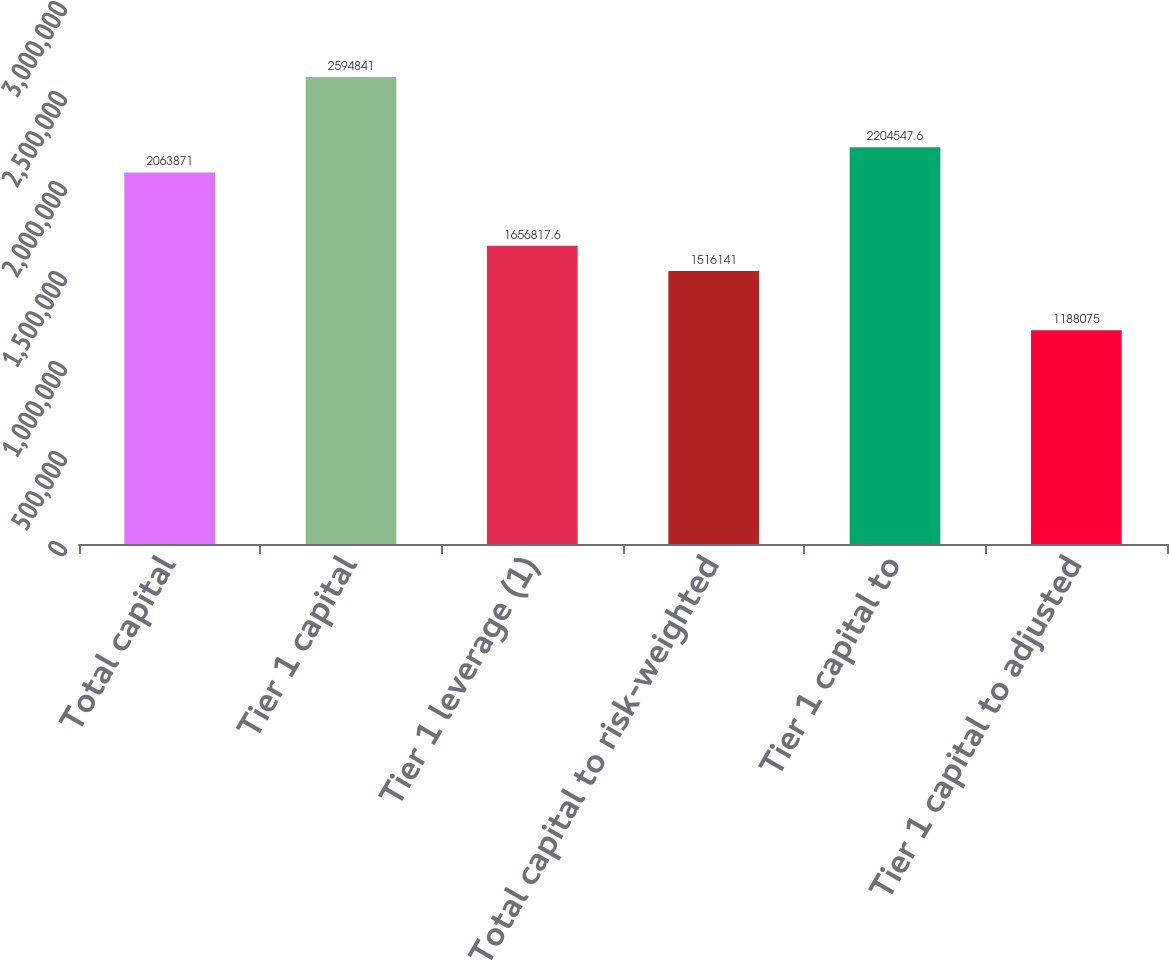<chart> <loc_0><loc_0><loc_500><loc_500><bar_chart><fcel>Total capital<fcel>Tier 1 capital<fcel>Tier 1 leverage (1)<fcel>Total capital to risk-weighted<fcel>Tier 1 capital to<fcel>Tier 1 capital to adjusted<nl><fcel>2.06387e+06<fcel>2.59484e+06<fcel>1.65682e+06<fcel>1.51614e+06<fcel>2.20455e+06<fcel>1.18808e+06<nl></chart> 